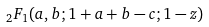<formula> <loc_0><loc_0><loc_500><loc_500>\, _ { 2 } F _ { 1 } ( a , b ; 1 + a + b - c ; 1 - z )</formula> 